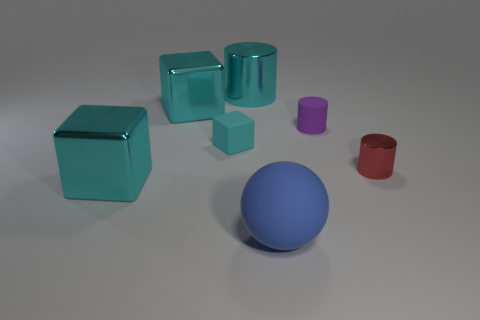Is the shape of the purple thing the same as the tiny cyan rubber object?
Make the answer very short. No. How many cylinders are both to the right of the big cyan metal cylinder and behind the cyan rubber object?
Ensure brevity in your answer.  1. Is there anything else of the same color as the tiny shiny cylinder?
Your response must be concise. No. There is a cyan thing that is the same material as the large blue sphere; what shape is it?
Offer a terse response. Cube. Do the blue thing and the cyan metallic cylinder have the same size?
Your answer should be very brief. Yes. Do the cylinder that is left of the blue object and the ball have the same material?
Offer a terse response. No. There is a cyan metal block that is behind the metallic thing that is on the right side of the big cyan cylinder; how many red metal objects are left of it?
Offer a very short reply. 0. There is a big object that is on the right side of the cyan cylinder; is its shape the same as the cyan matte object?
Offer a terse response. No. How many objects are either rubber things or large cyan shiny things in front of the red cylinder?
Give a very brief answer. 4. Are there more shiny cylinders that are behind the tiny red object than small yellow metallic things?
Ensure brevity in your answer.  Yes. 